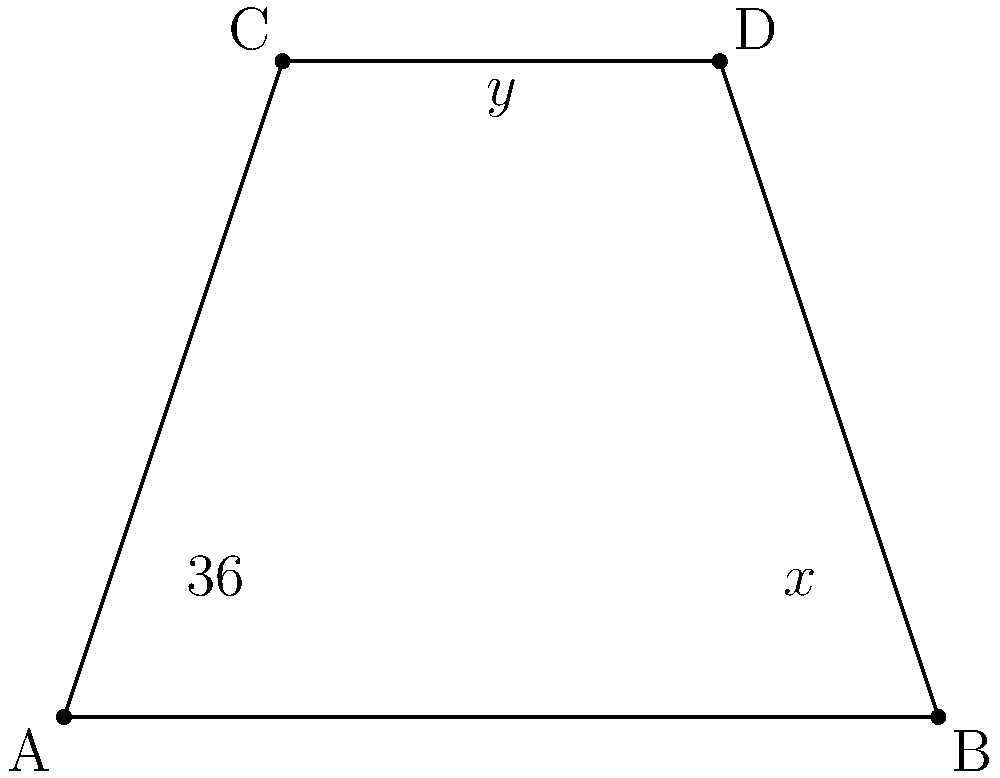In the DNA double helix structure, the angle between the base pairs and the axis of the helix is critical. Consider the diagram representing a simplified cross-section of DNA, where ABCD is a parallelogram. If the angle at vertex A is $36°$ and the angle between AC and BD is $y°$, what is the value of $x + y$? Let's approach this step-by-step:

1) In a parallelogram, opposite angles are equal. So, $\angle DAB = \angle BCD = 36°$.

2) The sum of angles in a parallelogram is $360°$. Therefore:
   $\angle DAB + \angle ABC + \angle BCD + \angle CDA = 360°$
   $36° + \angle ABC + 36° + \angle CDA = 360°$
   $\angle ABC + \angle CDA = 360° - 72° = 288°$

3) In a parallelogram, adjacent angles are supplementary (sum to $180°$). So:
   $\angle ABC + 36° = 180°$
   $\angle ABC = 144°$

4) Now we can find $\angle CDA$:
   $\angle CDA = 288° - 144° = 144°$

5) The diagonals of a parallelogram bisect each other. This means that $\triangle ACD$ is congruent to $\triangle ACB$.

6) In $\triangle ACD$:
   $\angle CAD + \angle ACD + 36° = 180°$ (sum of angles in a triangle)
   $\angle CAD + \angle ACD = 144°$

7) Since $\angle CAD = \angle CAB$ (as AC bisects $\angle DAB$), we can say:
   $2\angle CAD = 144°$
   $\angle CAD = 72°$

8) Now, $x° = 144° - 72° = 72°$

9) The angle between the diagonals, $y°$, can be found:
   $y° = 180° - 2(36°) = 108°$ (as the diagonals bisect the angles of the parallelogram)

10) Therefore, $x + y = 72° + 108° = 180°$
Answer: $180°$ 